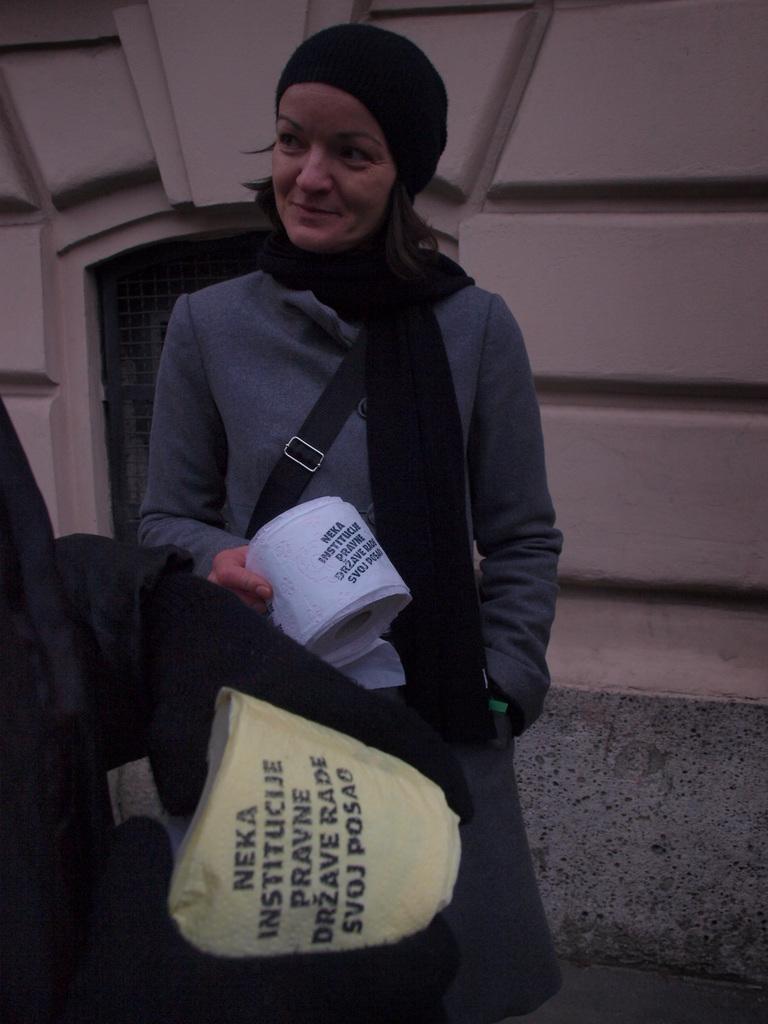How would you summarize this image in a sentence or two? In this image there is person standing and holding an object, there is a person truncated towards the left of the image, at the background of the image there is a wall truncated. 